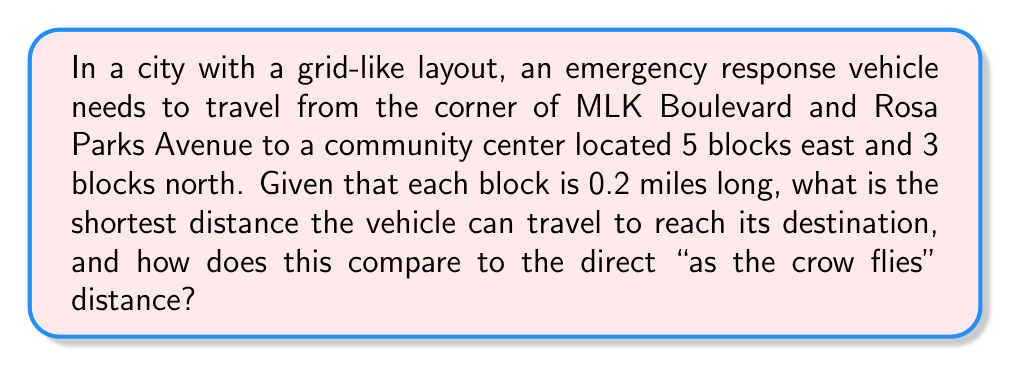Teach me how to tackle this problem. Let's approach this step-by-step:

1) First, we need to understand that in a grid-like city, the shortest path will always be the sum of the horizontal and vertical distances. This is known as the Manhattan distance.

2) The vehicle needs to travel:
   - 5 blocks east
   - 3 blocks north

3) Each block is 0.2 miles long, so:
   - East distance = $5 \times 0.2 = 1$ mile
   - North distance = $3 \times 0.2 = 0.6$ miles

4) The shortest path (Manhattan distance) is:
   $$ \text{Shortest path} = 1 + 0.6 = 1.6 \text{ miles} $$

5) To find the "as the crow flies" distance, we need to use the Pythagorean theorem:
   $$ \text{Direct distance} = \sqrt{1^2 + 0.6^2} = \sqrt{1.36} \approx 1.17 \text{ miles} $$

6) The difference between the shortest path and the direct distance is:
   $$ 1.6 - 1.17 = 0.43 \text{ miles} $$

This difference illustrates how the grid layout affects emergency response times, potentially impacting community safety.

[asy]
unitsize(1cm);
draw((0,0)--(5,0)--(5,3)--(0,3)--cycle);
draw((0,0)--(5,3),dashed);
label("Start", (0,0), SW);
label("End", (5,3), NE);
label("1 mile", (2.5,0), S);
label("0.6 miles", (5,1.5), E);
label("1.17 miles", (2.5,1.5), NW);
[/asy]
Answer: Shortest path: 1.6 miles; Direct distance: 1.17 miles; Difference: 0.43 miles 